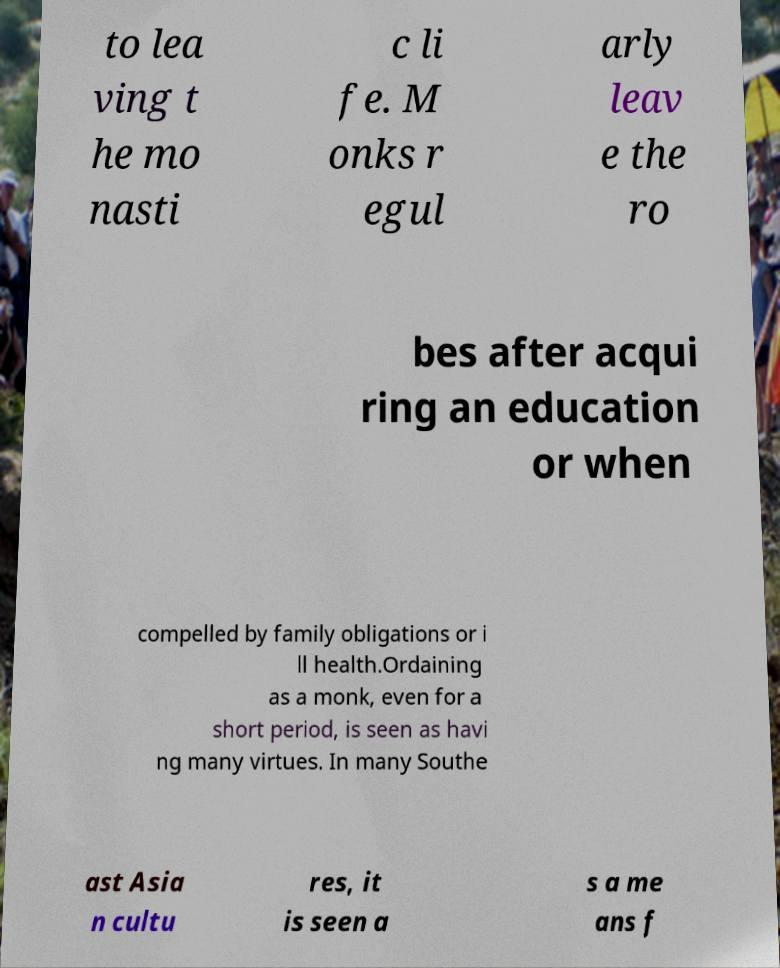Please read and relay the text visible in this image. What does it say? to lea ving t he mo nasti c li fe. M onks r egul arly leav e the ro bes after acqui ring an education or when compelled by family obligations or i ll health.Ordaining as a monk, even for a short period, is seen as havi ng many virtues. In many Southe ast Asia n cultu res, it is seen a s a me ans f 